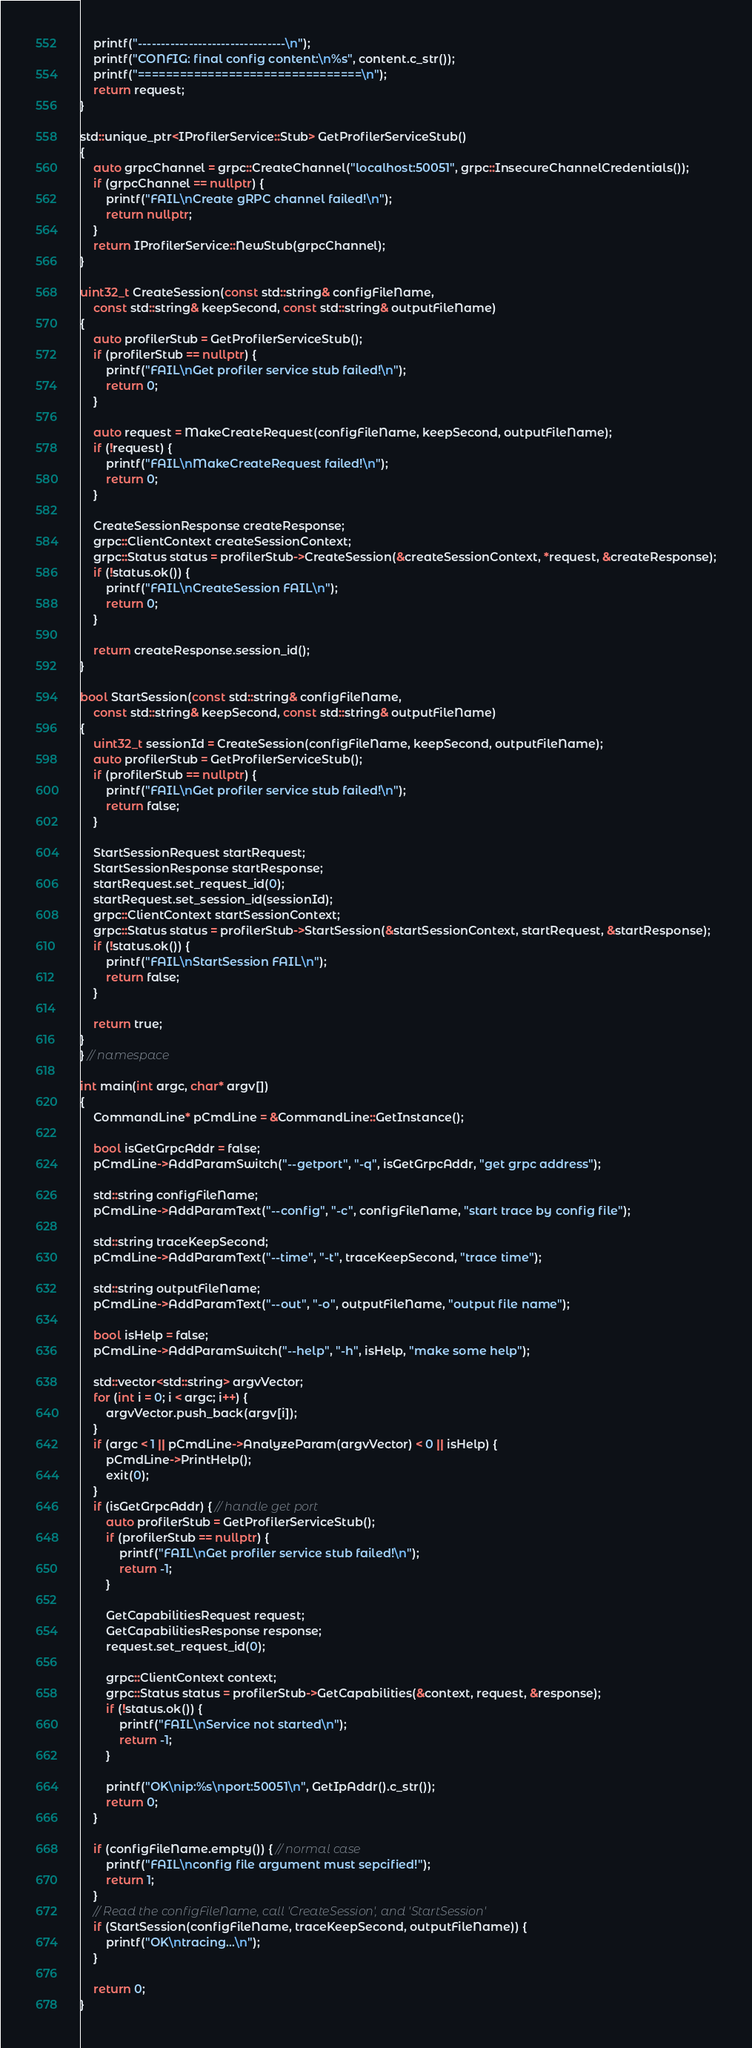Convert code to text. <code><loc_0><loc_0><loc_500><loc_500><_C++_>    printf("--------------------------------\n");
    printf("CONFIG: final config content:\n%s", content.c_str());
    printf("================================\n");
    return request;
}

std::unique_ptr<IProfilerService::Stub> GetProfilerServiceStub()
{
    auto grpcChannel = grpc::CreateChannel("localhost:50051", grpc::InsecureChannelCredentials());
    if (grpcChannel == nullptr) {
        printf("FAIL\nCreate gRPC channel failed!\n");
        return nullptr;
    }
    return IProfilerService::NewStub(grpcChannel);
}

uint32_t CreateSession(const std::string& configFileName,
    const std::string& keepSecond, const std::string& outputFileName)
{
    auto profilerStub = GetProfilerServiceStub();
    if (profilerStub == nullptr) {
        printf("FAIL\nGet profiler service stub failed!\n");
        return 0;
    }

    auto request = MakeCreateRequest(configFileName, keepSecond, outputFileName);
    if (!request) {
        printf("FAIL\nMakeCreateRequest failed!\n");
        return 0;
    }

    CreateSessionResponse createResponse;
    grpc::ClientContext createSessionContext;
    grpc::Status status = profilerStub->CreateSession(&createSessionContext, *request, &createResponse);
    if (!status.ok()) {
        printf("FAIL\nCreateSession FAIL\n");
        return 0;
    }

    return createResponse.session_id();
}

bool StartSession(const std::string& configFileName,
    const std::string& keepSecond, const std::string& outputFileName)
{
    uint32_t sessionId = CreateSession(configFileName, keepSecond, outputFileName);
    auto profilerStub = GetProfilerServiceStub();
    if (profilerStub == nullptr) {
        printf("FAIL\nGet profiler service stub failed!\n");
        return false;
    }

    StartSessionRequest startRequest;
    StartSessionResponse startResponse;
    startRequest.set_request_id(0);
    startRequest.set_session_id(sessionId);
    grpc::ClientContext startSessionContext;
    grpc::Status status = profilerStub->StartSession(&startSessionContext, startRequest, &startResponse);
    if (!status.ok()) {
        printf("FAIL\nStartSession FAIL\n");
        return false;
    }

    return true;
}
} // namespace

int main(int argc, char* argv[])
{
    CommandLine* pCmdLine = &CommandLine::GetInstance();

    bool isGetGrpcAddr = false;
    pCmdLine->AddParamSwitch("--getport", "-q", isGetGrpcAddr, "get grpc address");

    std::string configFileName;
    pCmdLine->AddParamText("--config", "-c", configFileName, "start trace by config file");

    std::string traceKeepSecond;
    pCmdLine->AddParamText("--time", "-t", traceKeepSecond, "trace time");

    std::string outputFileName;
    pCmdLine->AddParamText("--out", "-o", outputFileName, "output file name");

    bool isHelp = false;
    pCmdLine->AddParamSwitch("--help", "-h", isHelp, "make some help");

    std::vector<std::string> argvVector;
    for (int i = 0; i < argc; i++) {
        argvVector.push_back(argv[i]);
    }
    if (argc < 1 || pCmdLine->AnalyzeParam(argvVector) < 0 || isHelp) {
        pCmdLine->PrintHelp();
        exit(0);
    }
    if (isGetGrpcAddr) { // handle get port
        auto profilerStub = GetProfilerServiceStub();
        if (profilerStub == nullptr) {
            printf("FAIL\nGet profiler service stub failed!\n");
            return -1;
        }

        GetCapabilitiesRequest request;
        GetCapabilitiesResponse response;
        request.set_request_id(0);

        grpc::ClientContext context;
        grpc::Status status = profilerStub->GetCapabilities(&context, request, &response);
        if (!status.ok()) {
            printf("FAIL\nService not started\n");
            return -1;
        }

        printf("OK\nip:%s\nport:50051\n", GetIpAddr().c_str());
        return 0;
    }

    if (configFileName.empty()) { // normal case
        printf("FAIL\nconfig file argument must sepcified!");
        return 1;
    }
    // Read the configFileName, call 'CreateSession', and 'StartSession'
    if (StartSession(configFileName, traceKeepSecond, outputFileName)) {
        printf("OK\ntracing...\n");
    }

    return 0;
}
</code> 